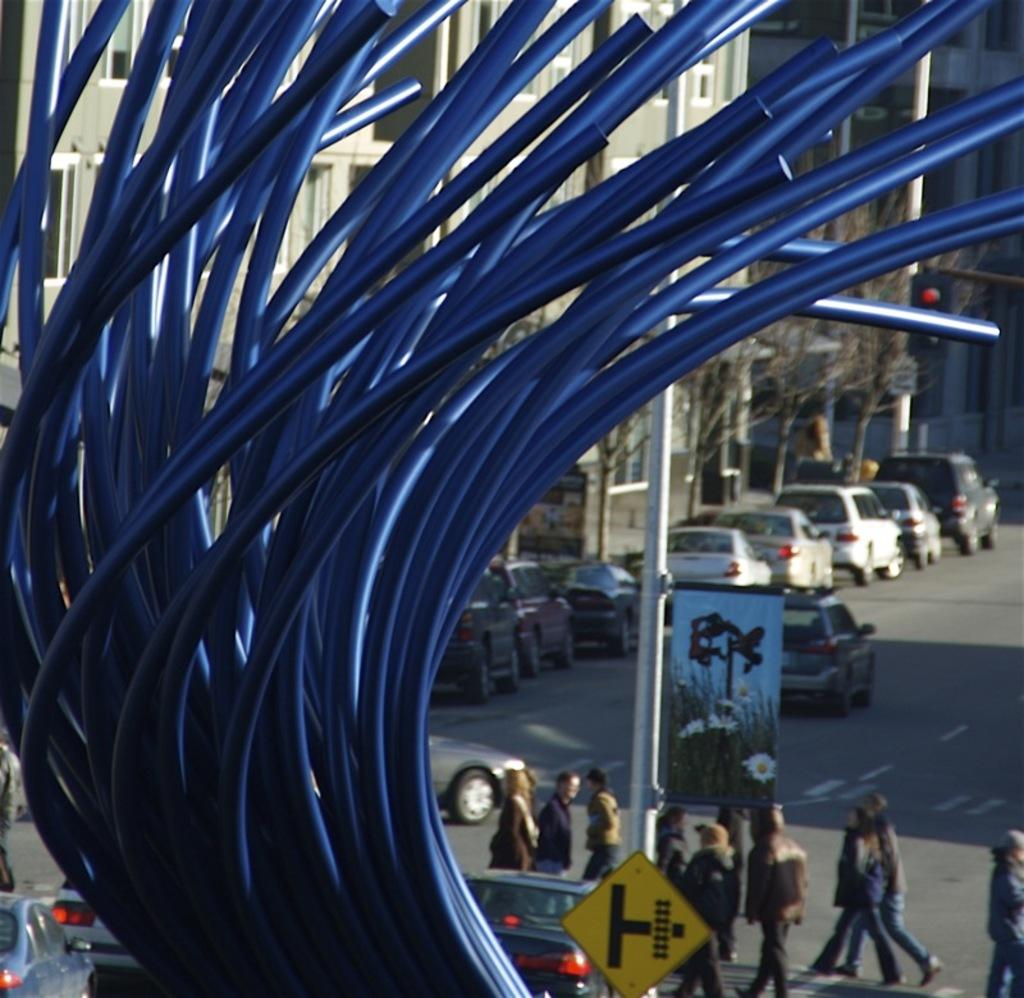What type of structures can be seen in the image? There are buildings in the image. What architectural features can be observed on the buildings? Windows are visible in the image. What natural elements are present in the image? There are trees in the image. What traffic control devices are present in the image? Traffic signals are present in the image. What type of vertical structures can be seen in the image? Poles are visible in the image. What type of signage is present in the image? Signboards are present in the image. What type of transportation is visible in the image? Vehicles are visible in the image. Are there any human figures present in the image? Yes, there are people in the image. What color object can be seen in the image? There is a blue color object in the image. What type of agreement was reached during the minute-long discovery in the image? There is no indication of an agreement or discovery in the image; it primarily features buildings, trees, traffic signals, poles, signboards, vehicles, and people. 